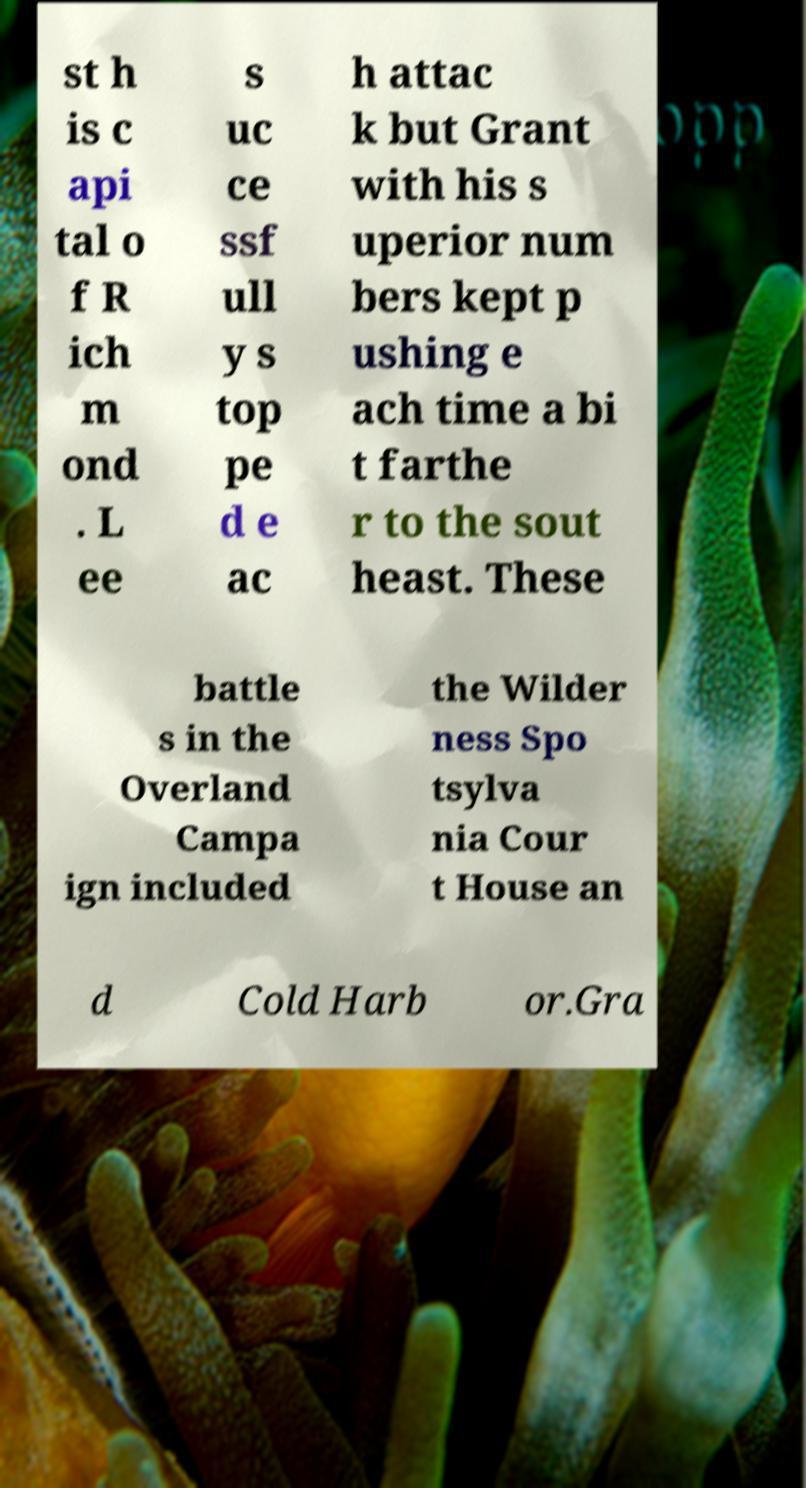Please read and relay the text visible in this image. What does it say? st h is c api tal o f R ich m ond . L ee s uc ce ssf ull y s top pe d e ac h attac k but Grant with his s uperior num bers kept p ushing e ach time a bi t farthe r to the sout heast. These battle s in the Overland Campa ign included the Wilder ness Spo tsylva nia Cour t House an d Cold Harb or.Gra 